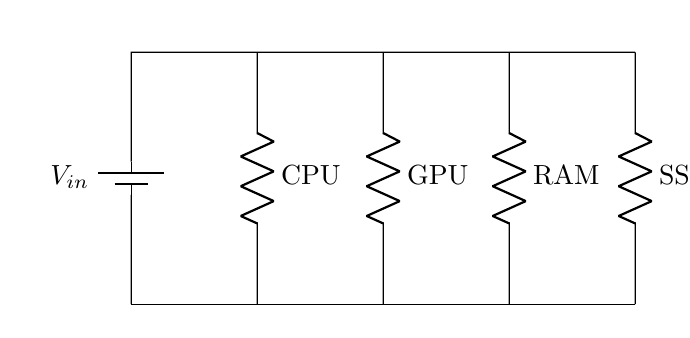What are the components connected in parallel? The components in this parallel circuit are CPU, GPU, RAM, and SSD, which are all connected to the same voltage source.
Answer: CPU, GPU, RAM, SSD What is the purpose of using a parallel circuit in this build? A parallel circuit ensures that each component receives the same voltage, allowing them to operate independently without affecting each other's performance.
Answer: To distribute voltage evenly How many resistors are there in this circuit? There are four resistors, one for each connected component (CPU, GPU, RAM, and SSD).
Answer: Four What is the total voltage supplied to the circuit? The total voltage supplied is V-in, which is the voltage of the battery shown in the diagram. This voltage is the same across all components since they are in parallel.
Answer: V-in What happens if one component fails in a parallel circuit? If one component fails, the other components will continue to function normally because they are connected in parallel, which allows alternative paths for current to flow.
Answer: Other components remain functional What type of circuit configuration is shown in the diagram? The circuit configuration shown is a parallel circuit as indicated by the multiple branches connected to a single voltage source.
Answer: Parallel circuit 